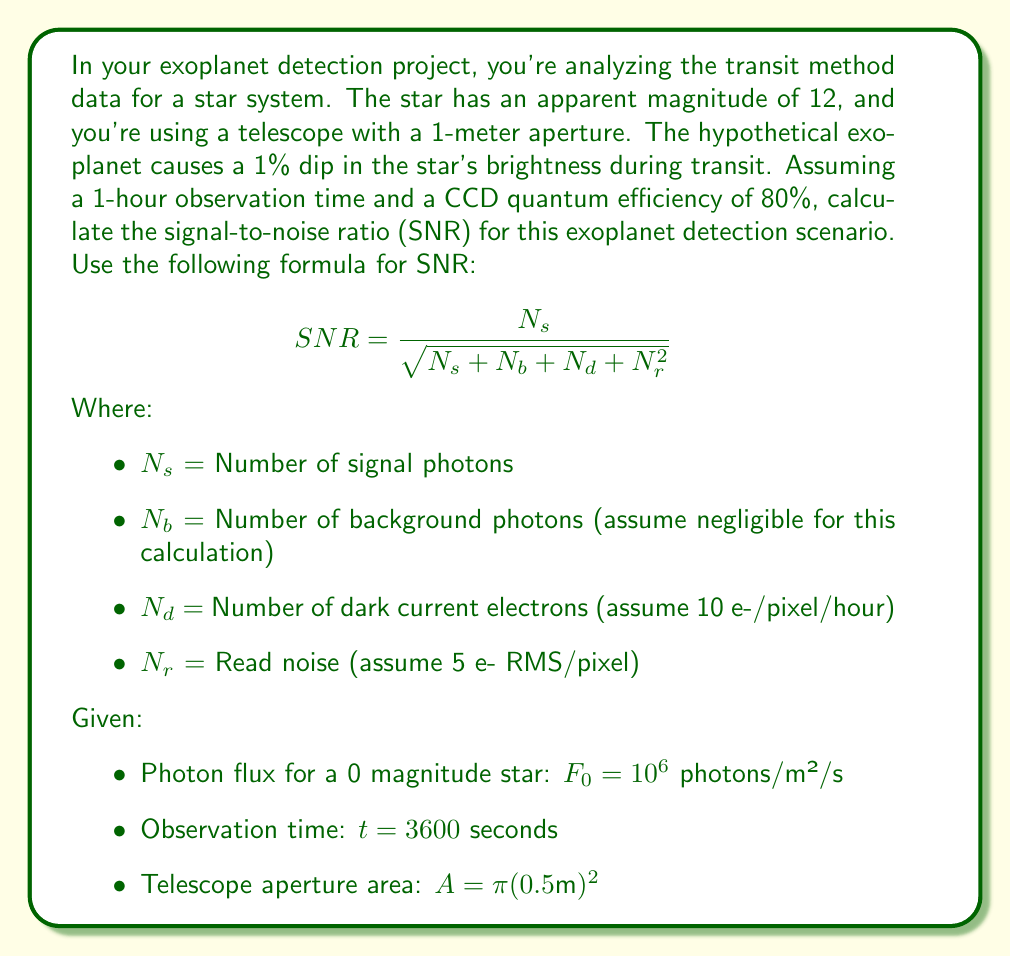Help me with this question. To solve this problem, we'll follow these steps:

1) Calculate the photon flux for the star:
   The star has an apparent magnitude of 12. We can calculate its photon flux using the magnitude equation:
   $$ F = F_0 \cdot 10^{-0.4m} $$
   where $m$ is the apparent magnitude.
   
   $$ F = 10^6 \cdot 10^{-0.4 \cdot 12} = 6309.57 \text{ photons/m²/s} $$

2) Calculate the number of signal photons ($N_s$):
   $$ N_s = F \cdot A \cdot t \cdot \text{QE} \cdot 0.01 $$
   where 0.01 is the 1% dip in brightness.
   
   $$ N_s = 6309.57 \cdot \pi (0.5)^2 \cdot 3600 \cdot 0.8 \cdot 0.01 = 7140.64 \text{ photons} $$

3) Calculate the noise components:
   $N_b = 0$ (given as negligible)
   $N_d = 10 \text{ e-/pixel/hour} = 10 \text{ e-/pixel}$
   $N_r = 5 \text{ e- RMS/pixel}$

4) Apply the SNR formula:
   $$ SNR = \frac{7140.64}{\sqrt{7140.64 + 0 + 10 + 5^2}} $$
   $$ SNR = \frac{7140.64}{\sqrt{7175.64}} $$
   $$ SNR = 84.24 $$
Answer: The signal-to-noise ratio (SNR) for the exoplanet detection scenario is approximately 84.24. 